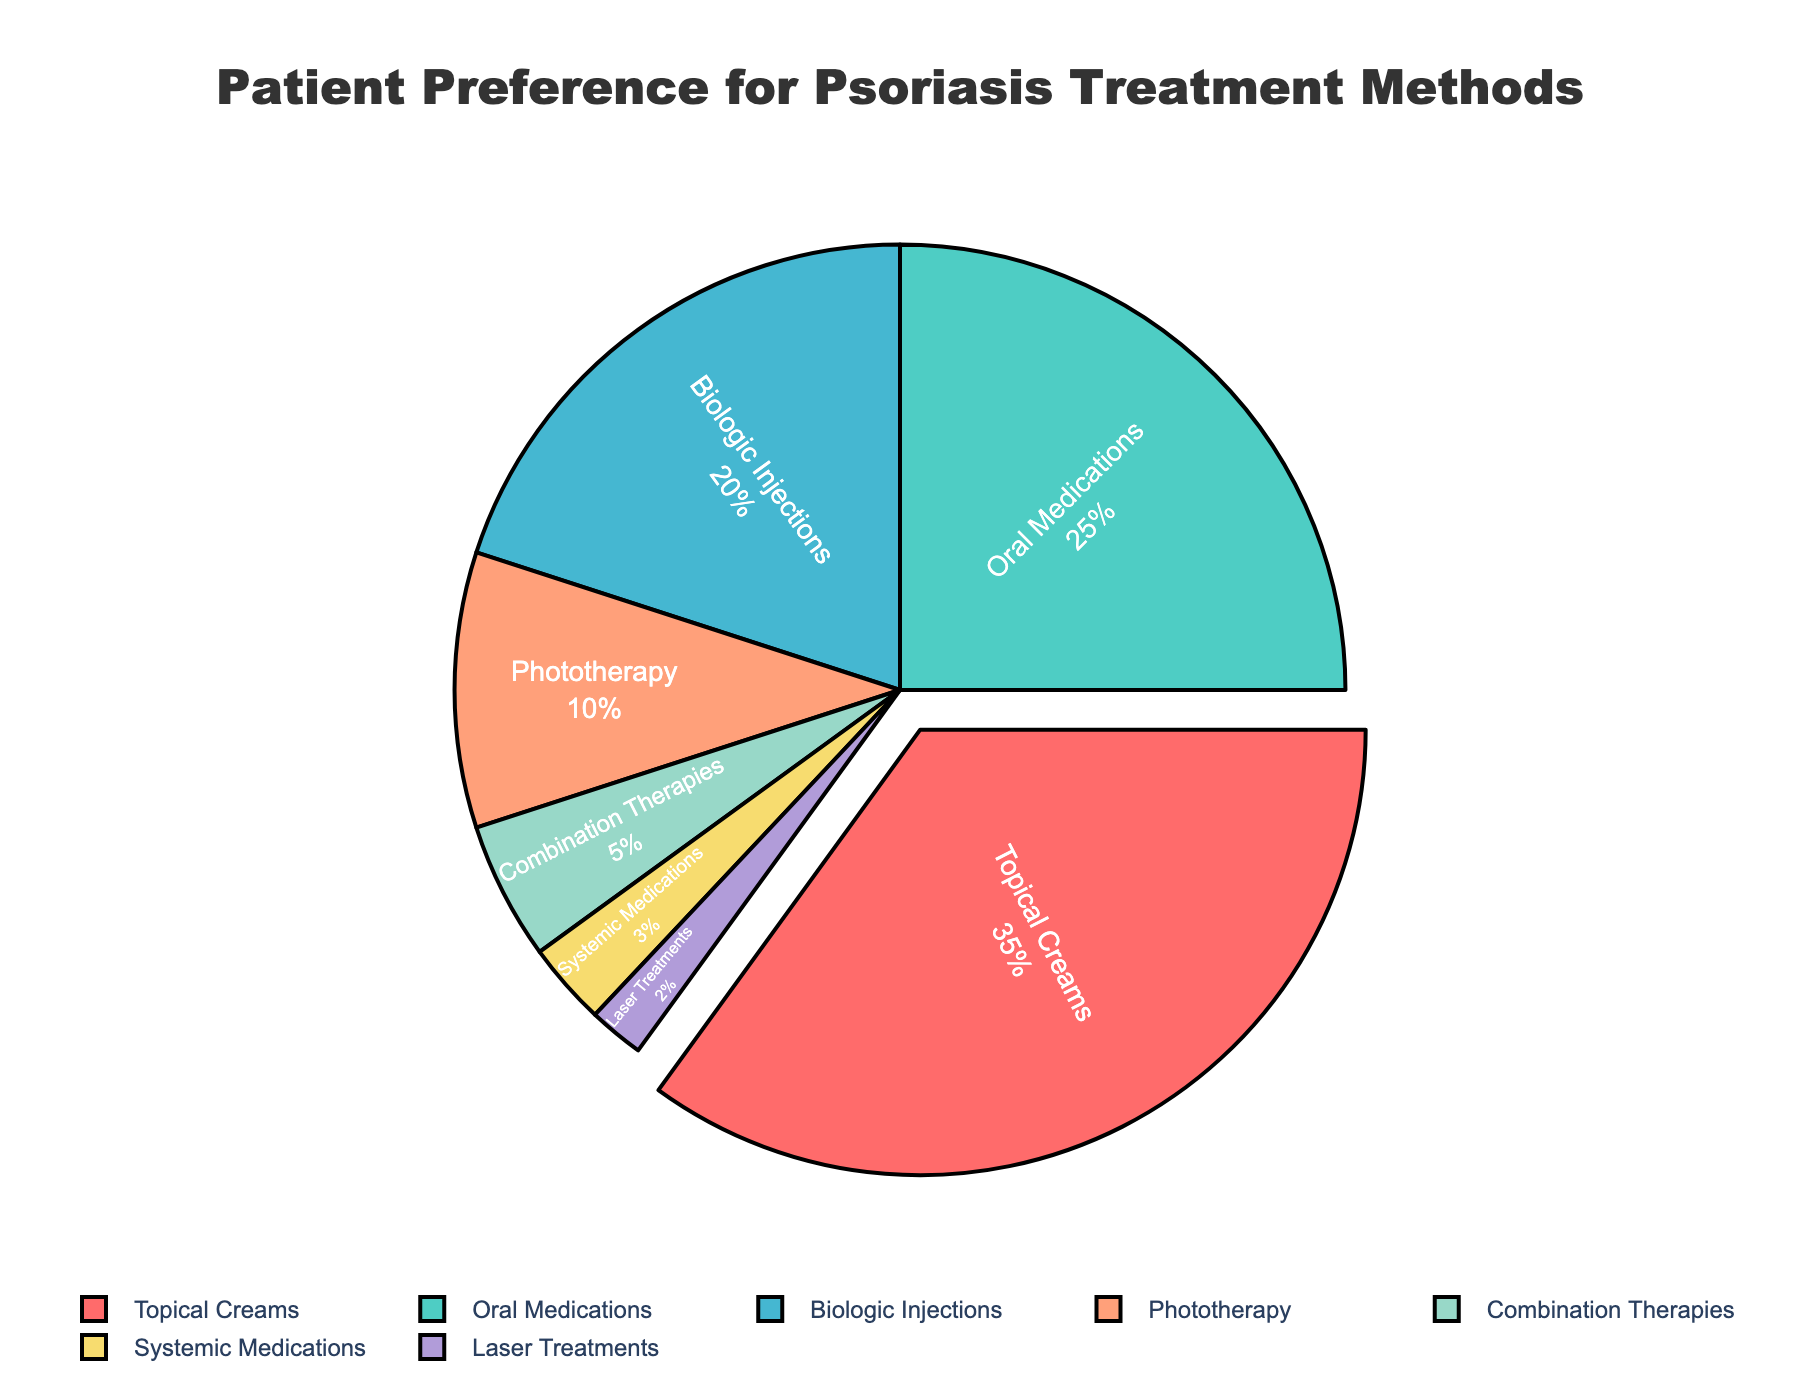What method has the highest percentage of patient preference? The pie chart shows that Topical Creams have a 35% preference, which is visually the largest segment and is pulled out from the pie.
Answer: Topical Creams Which treatment method is preferred by the smallest percentage of patients? The pie chart shows that Laser Treatments have the smallest segment, with a 2% preference.
Answer: Laser Treatments What is the combined preference percentage for Phototherapy and Combination Therapies? According to the chart, Phototherapy is preferred by 10% of patients and Combination Therapies by 5%. Adding these together is 10% + 5% = 15%.
Answer: 15% Compare the patient preference between Biologic Injections and Systemic Medications. Which one is preferred more and by what percentage? Biologic Injections have a 20% preference, whereas Systemic Medications have a 3% preference. The difference is 20% - 3% = 17%. Biologic Injections are preferred more by 17%.
Answer: Biologic Injections by 17% How much more popular are Oral Medications compared to Laser Treatments? The pie chart shows that Oral Medications have a 25% preference, while Laser Treatments have a 2% preference. The difference is 25% - 2% = 23%.
Answer: 23% Which parts of the pie are represented in shades of blue and green? By observing the pie chart, Phototherapy is represented by a shade of blue, and Biologic Injections are represented by a shade of green.
Answer: Phototherapy and Biologic Injections If you combined the percentages of Laser Treatments, Systemic Medications, and Combination Therapies, would they together surpass the preference for Oral Medications? Laser Treatments (2%), Systemic Medications (3%), and Combination Therapies (5%) add up to 2% + 3% + 5% = 10%. Since Oral Medications have a 25% preference, 10% does not surpass 25%.
Answer: No Describe the relative size and features of the segment representing Topical Creams. The segment for Topical Creams is the largest in the pie chart (35%). It is visually emphasized by being pulled out from the pie and is presented in a distinct color.
Answer: Largest segment, pulled out, and distinct color What is the difference in preference percentage between the top two preferred treatment methods? Topical Creams have a 35% preference and Oral Medications have a 25% preference. The difference is 35% - 25% = 10%.
Answer: 10% On which side of the chart (left/right) do systemic medications appear, and what is their percentage? Systemic Medications appear on the right side of the chart and have a 3% preference.
Answer: Right side, 3% 